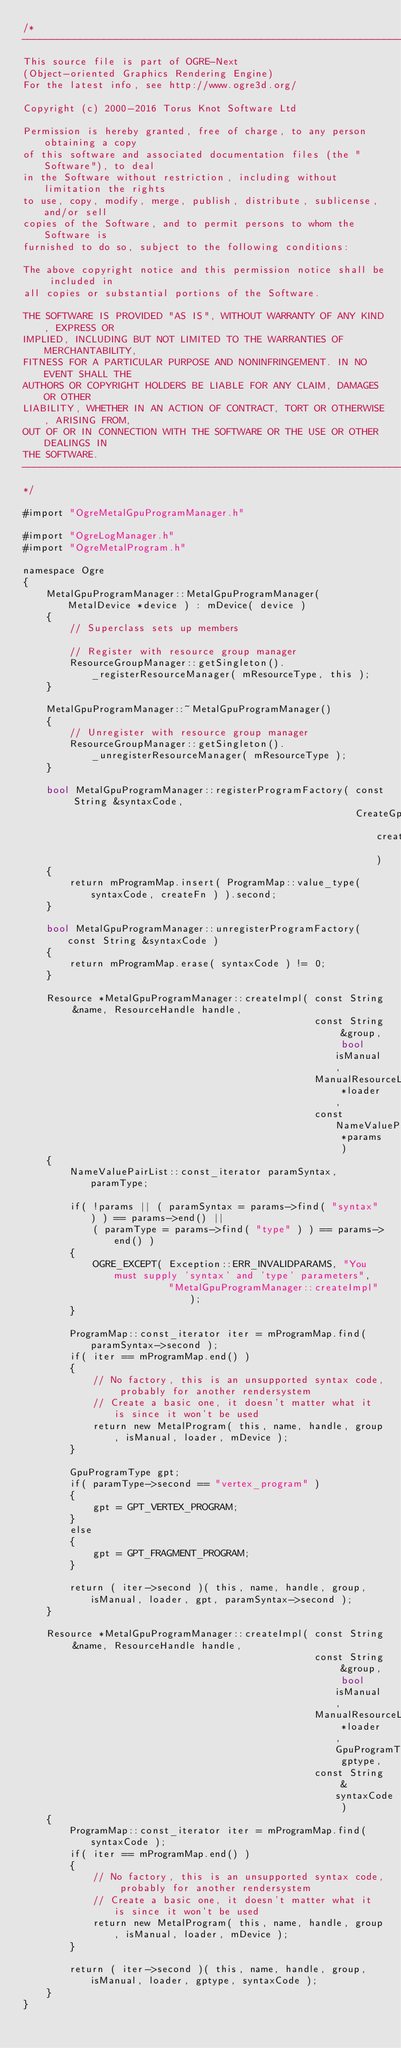<code> <loc_0><loc_0><loc_500><loc_500><_ObjectiveC_>/*
-----------------------------------------------------------------------------
This source file is part of OGRE-Next
(Object-oriented Graphics Rendering Engine)
For the latest info, see http://www.ogre3d.org/

Copyright (c) 2000-2016 Torus Knot Software Ltd

Permission is hereby granted, free of charge, to any person obtaining a copy
of this software and associated documentation files (the "Software"), to deal
in the Software without restriction, including without limitation the rights
to use, copy, modify, merge, publish, distribute, sublicense, and/or sell
copies of the Software, and to permit persons to whom the Software is
furnished to do so, subject to the following conditions:

The above copyright notice and this permission notice shall be included in
all copies or substantial portions of the Software.

THE SOFTWARE IS PROVIDED "AS IS", WITHOUT WARRANTY OF ANY KIND, EXPRESS OR
IMPLIED, INCLUDING BUT NOT LIMITED TO THE WARRANTIES OF MERCHANTABILITY,
FITNESS FOR A PARTICULAR PURPOSE AND NONINFRINGEMENT. IN NO EVENT SHALL THE
AUTHORS OR COPYRIGHT HOLDERS BE LIABLE FOR ANY CLAIM, DAMAGES OR OTHER
LIABILITY, WHETHER IN AN ACTION OF CONTRACT, TORT OR OTHERWISE, ARISING FROM,
OUT OF OR IN CONNECTION WITH THE SOFTWARE OR THE USE OR OTHER DEALINGS IN
THE SOFTWARE.
-----------------------------------------------------------------------------
*/

#import "OgreMetalGpuProgramManager.h"

#import "OgreLogManager.h"
#import "OgreMetalProgram.h"

namespace Ogre
{
    MetalGpuProgramManager::MetalGpuProgramManager( MetalDevice *device ) : mDevice( device )
    {
        // Superclass sets up members

        // Register with resource group manager
        ResourceGroupManager::getSingleton()._registerResourceManager( mResourceType, this );
    }

    MetalGpuProgramManager::~MetalGpuProgramManager()
    {
        // Unregister with resource group manager
        ResourceGroupManager::getSingleton()._unregisterResourceManager( mResourceType );
    }

    bool MetalGpuProgramManager::registerProgramFactory( const String &syntaxCode,
                                                         CreateGpuProgramCallback createFn )
    {
        return mProgramMap.insert( ProgramMap::value_type( syntaxCode, createFn ) ).second;
    }

    bool MetalGpuProgramManager::unregisterProgramFactory( const String &syntaxCode )
    {
        return mProgramMap.erase( syntaxCode ) != 0;
    }

    Resource *MetalGpuProgramManager::createImpl( const String &name, ResourceHandle handle,
                                                  const String &group, bool isManual,
                                                  ManualResourceLoader *loader,
                                                  const NameValuePairList *params )
    {
        NameValuePairList::const_iterator paramSyntax, paramType;

        if( !params || ( paramSyntax = params->find( "syntax" ) ) == params->end() ||
            ( paramType = params->find( "type" ) ) == params->end() )
        {
            OGRE_EXCEPT( Exception::ERR_INVALIDPARAMS, "You must supply 'syntax' and 'type' parameters",
                         "MetalGpuProgramManager::createImpl" );
        }

        ProgramMap::const_iterator iter = mProgramMap.find( paramSyntax->second );
        if( iter == mProgramMap.end() )
        {
            // No factory, this is an unsupported syntax code, probably for another rendersystem
            // Create a basic one, it doesn't matter what it is since it won't be used
            return new MetalProgram( this, name, handle, group, isManual, loader, mDevice );
        }

        GpuProgramType gpt;
        if( paramType->second == "vertex_program" )
        {
            gpt = GPT_VERTEX_PROGRAM;
        }
        else
        {
            gpt = GPT_FRAGMENT_PROGRAM;
        }

        return ( iter->second )( this, name, handle, group, isManual, loader, gpt, paramSyntax->second );
    }

    Resource *MetalGpuProgramManager::createImpl( const String &name, ResourceHandle handle,
                                                  const String &group, bool isManual,
                                                  ManualResourceLoader *loader, GpuProgramType gptype,
                                                  const String &syntaxCode )
    {
        ProgramMap::const_iterator iter = mProgramMap.find( syntaxCode );
        if( iter == mProgramMap.end() )
        {
            // No factory, this is an unsupported syntax code, probably for another rendersystem
            // Create a basic one, it doesn't matter what it is since it won't be used
            return new MetalProgram( this, name, handle, group, isManual, loader, mDevice );
        }

        return ( iter->second )( this, name, handle, group, isManual, loader, gptype, syntaxCode );
    }
}
</code> 